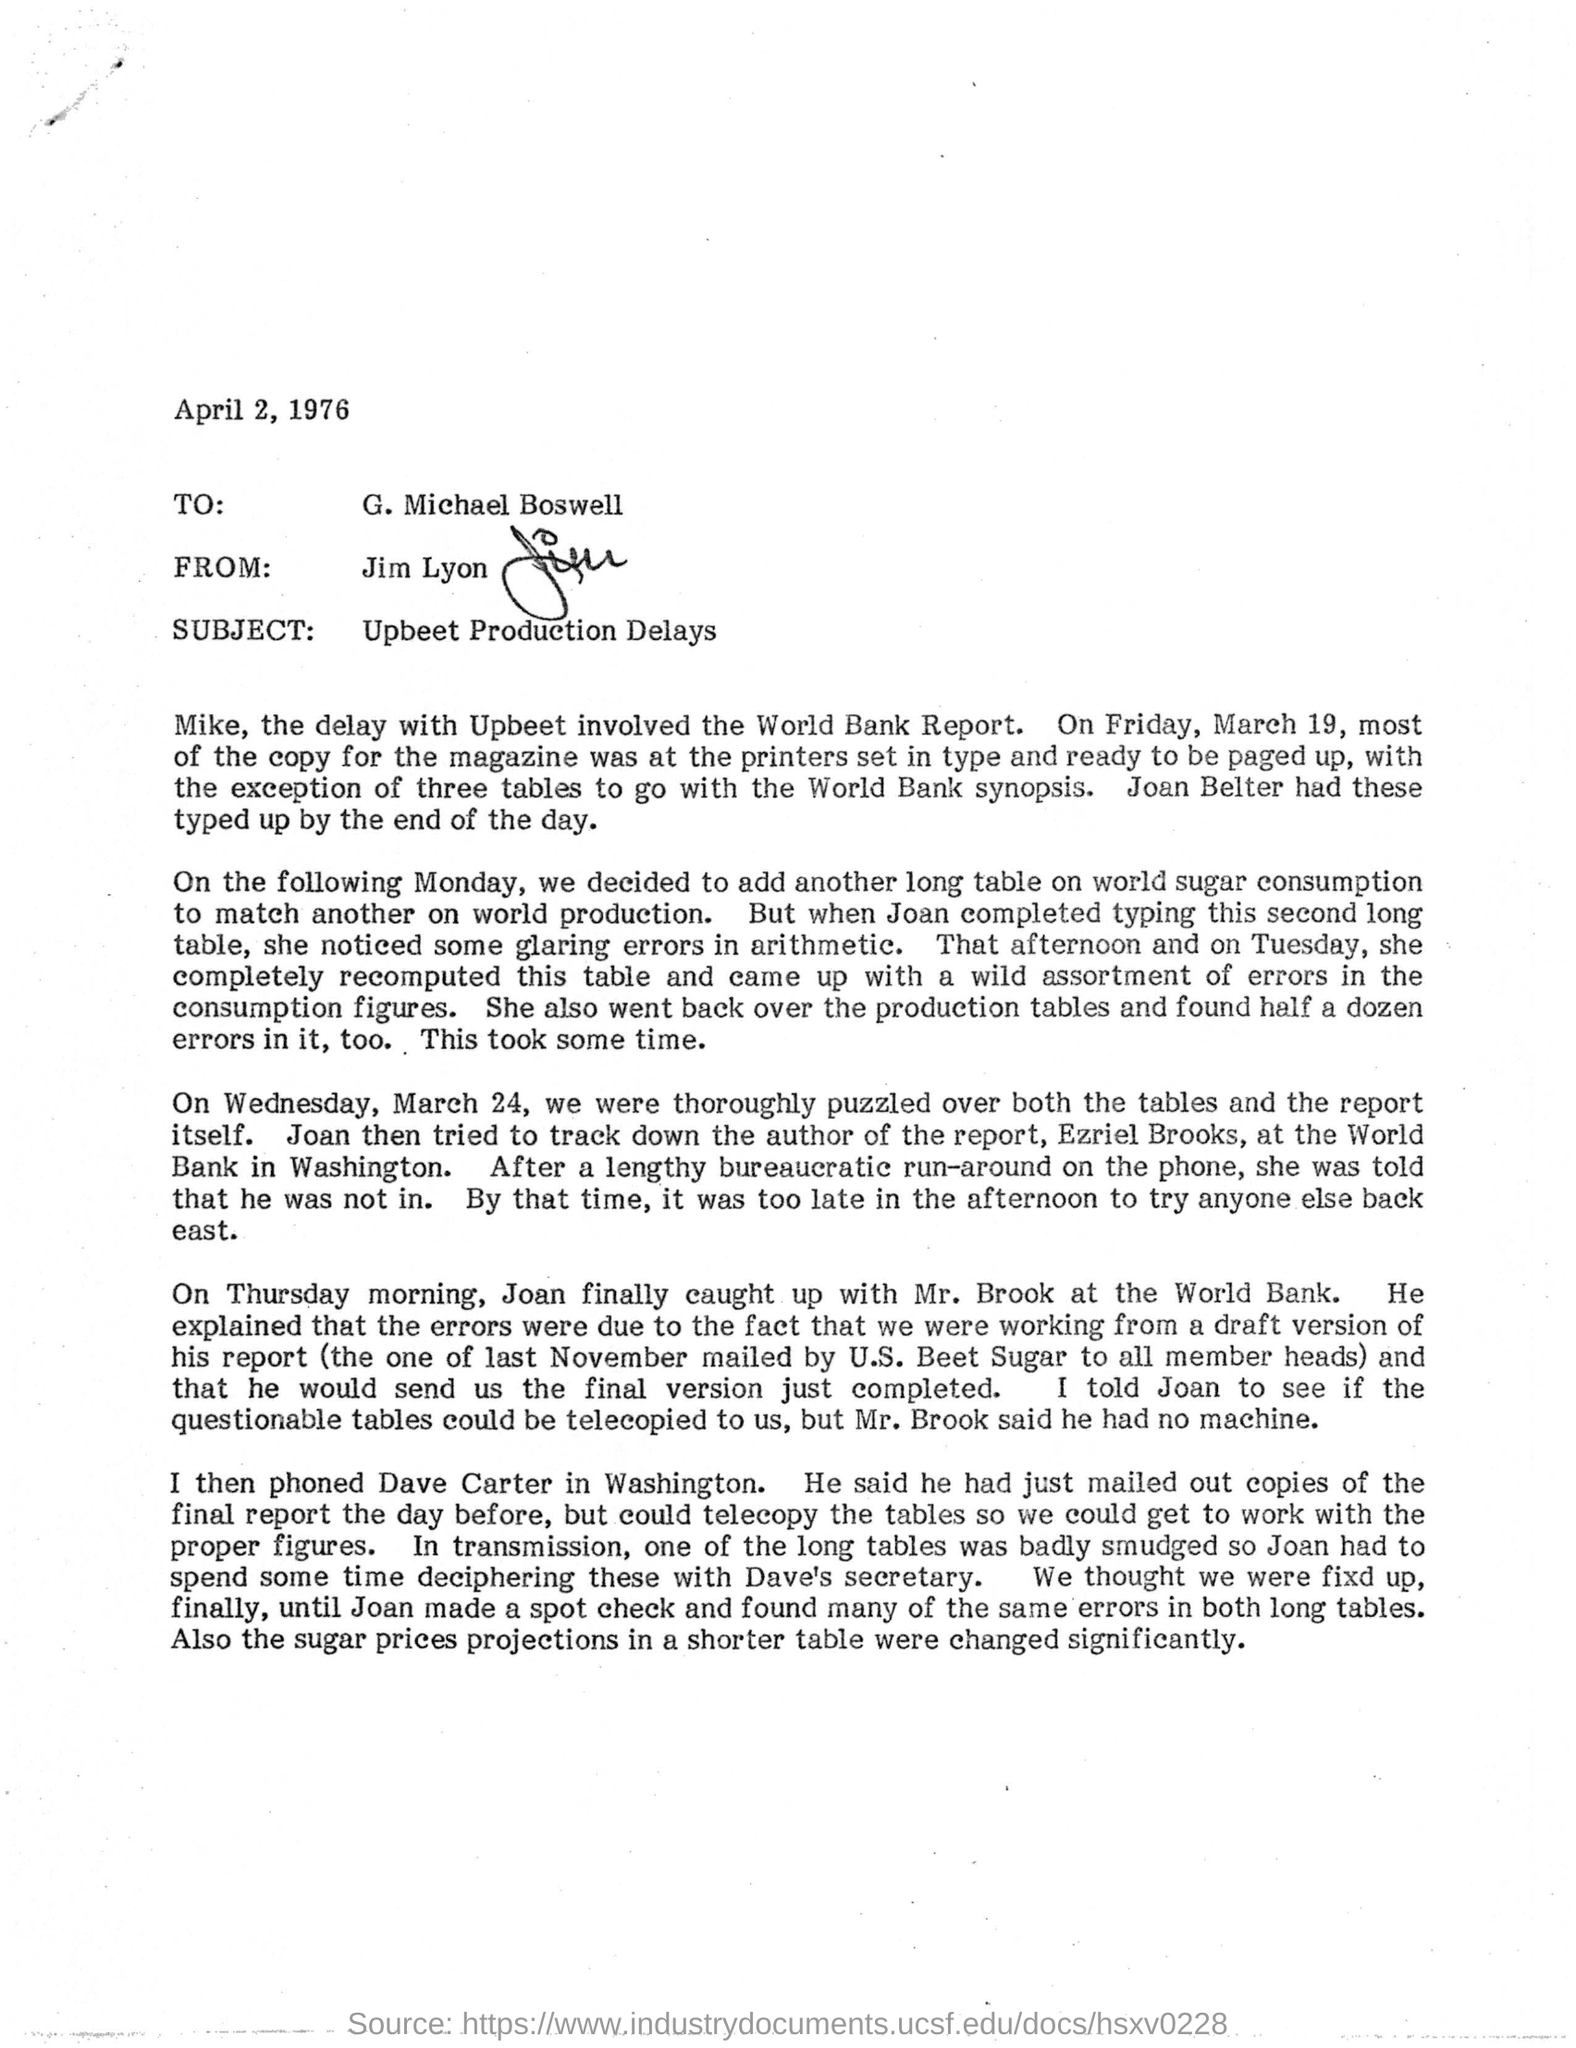To Whom is this letter addressed to? The letter is addressed to G. Michael Boswell, as stated at the beginning of the letter, just below the date, April 2, 1976. 